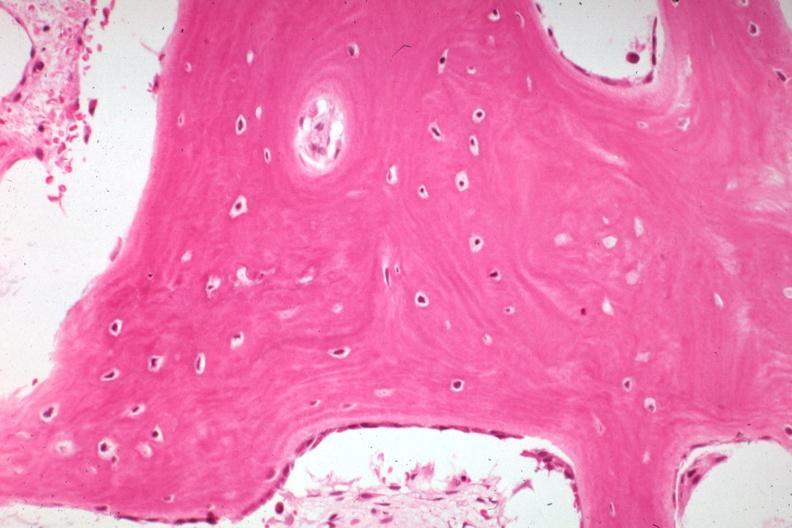s joints present?
Answer the question using a single word or phrase. Yes 